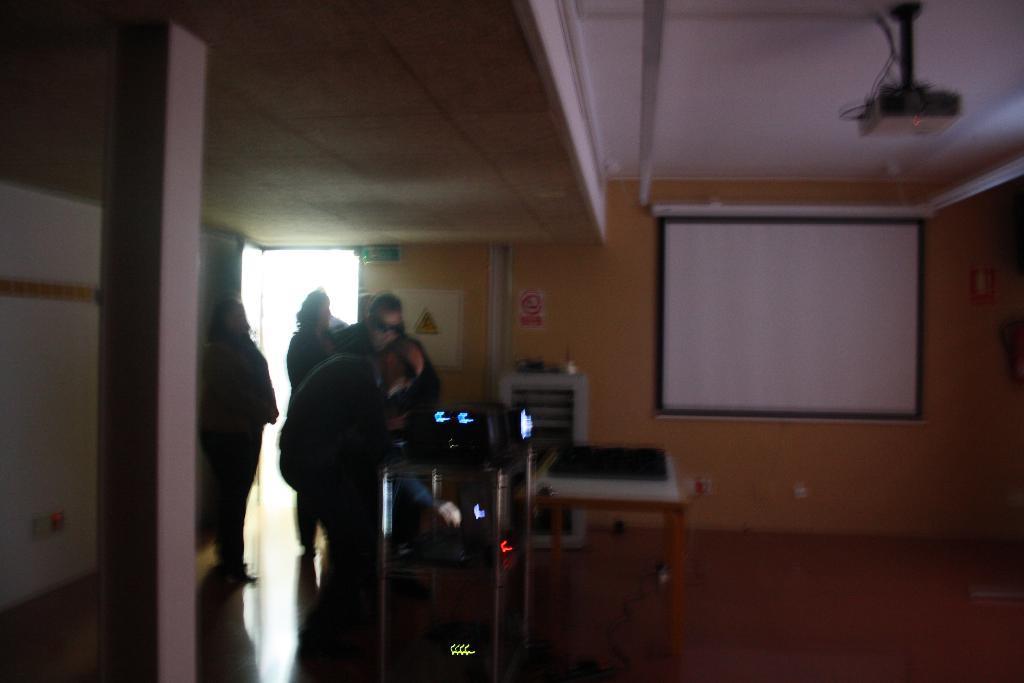How would you summarize this image in a sentence or two? This picture describes about group of people and we can see a projector and a projector screen. 